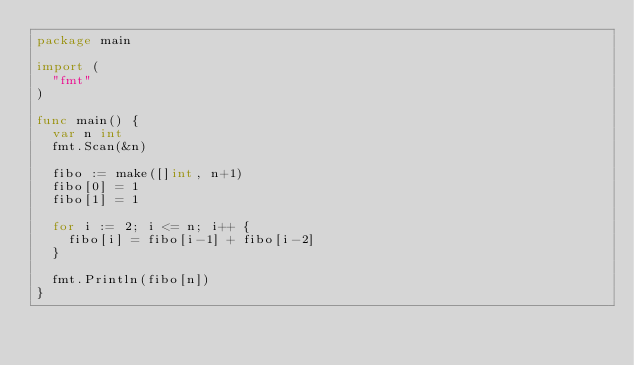Convert code to text. <code><loc_0><loc_0><loc_500><loc_500><_Go_>package main

import (
	"fmt"
)

func main() {
	var n int
	fmt.Scan(&n)

	fibo := make([]int, n+1)
	fibo[0] = 1
	fibo[1] = 1

	for i := 2; i <= n; i++ {
		fibo[i] = fibo[i-1] + fibo[i-2]
	}

	fmt.Println(fibo[n])
}

</code> 